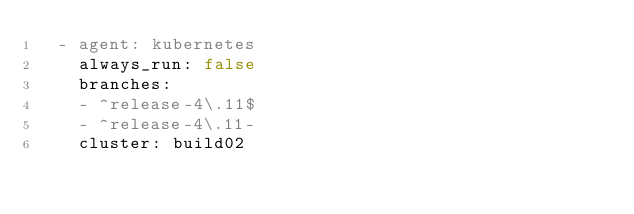Convert code to text. <code><loc_0><loc_0><loc_500><loc_500><_YAML_>  - agent: kubernetes
    always_run: false
    branches:
    - ^release-4\.11$
    - ^release-4\.11-
    cluster: build02</code> 